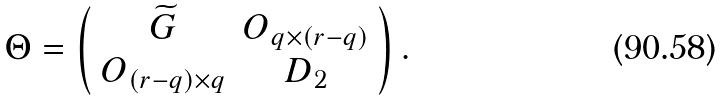<formula> <loc_0><loc_0><loc_500><loc_500>\Theta = \left ( \begin{array} { c c } \widetilde { G } & O _ { q \times \left ( r - q \right ) } \\ O _ { \left ( r - q \right ) \times q } & D _ { 2 } \end{array} \right ) .</formula> 